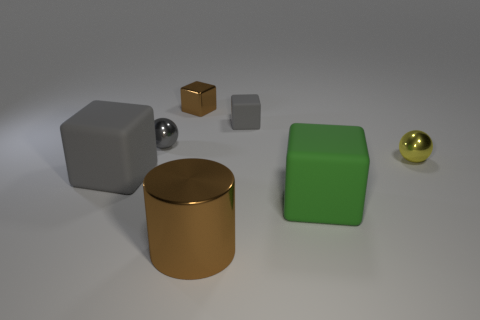Subtract all yellow balls. How many gray cubes are left? 2 Subtract all tiny brown shiny blocks. How many blocks are left? 3 Subtract all purple blocks. Subtract all cyan balls. How many blocks are left? 4 Add 1 large green matte cubes. How many objects exist? 8 Subtract all cubes. How many objects are left? 3 Subtract all shiny objects. Subtract all tiny cubes. How many objects are left? 1 Add 4 large green blocks. How many large green blocks are left? 5 Add 3 big metal things. How many big metal things exist? 4 Subtract 0 gray cylinders. How many objects are left? 7 